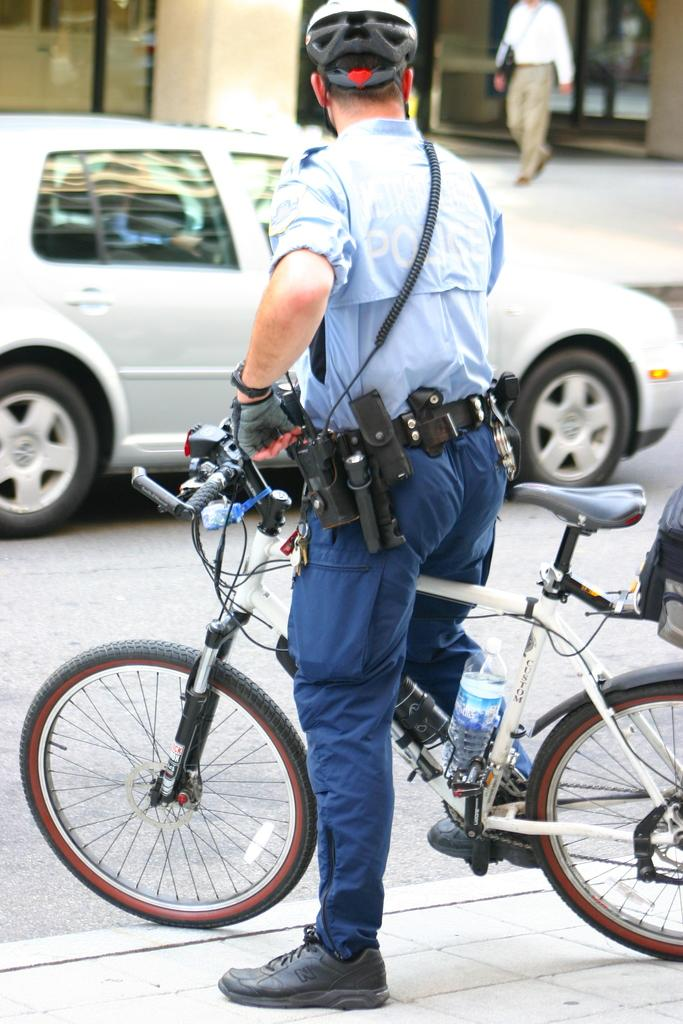What is the person in the image holding? The person is holding a book. What can be seen in the background of the image? There is a tree in the background of the image. What is the person sitting on? The person is sitting on a bench. What type of shoes is the person wearing in the image? The transcript does not mention shoes, so we cannot determine what type of shoes the person is wearing. 